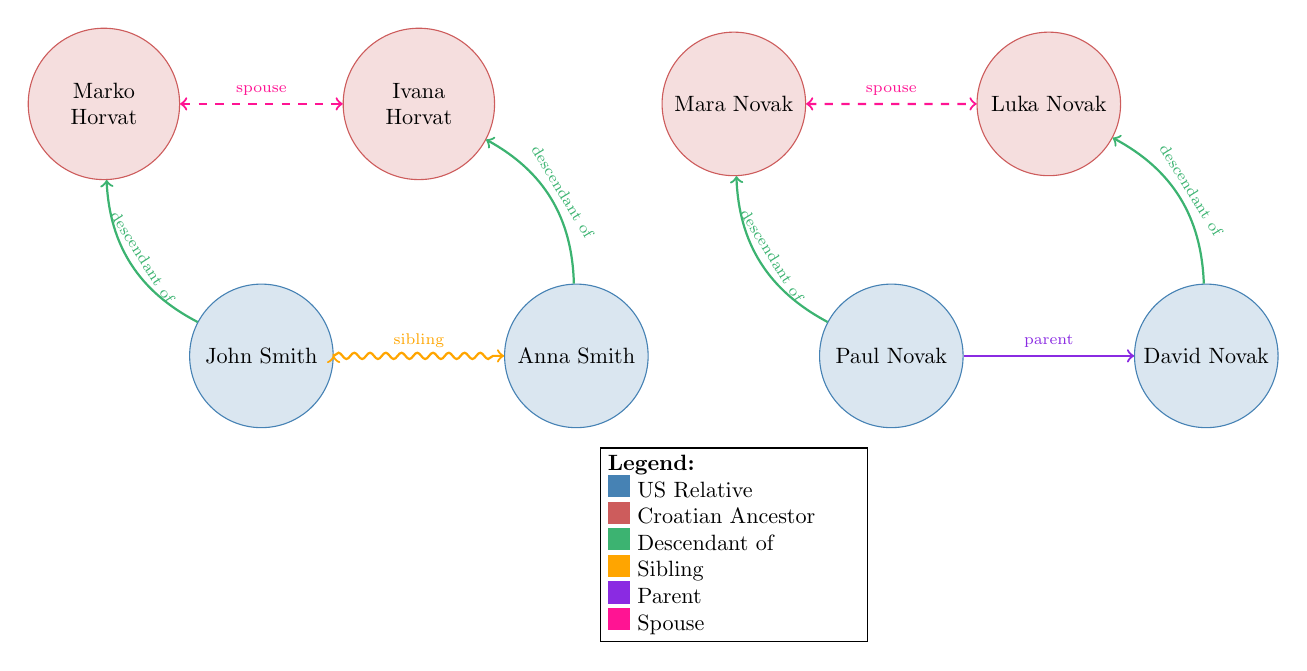What is the total number of nodes in the diagram? The diagram contains 8 distinct nodes, which represent both U.S. relatives and Croatian ancestors.
Answer: 8 Who is the spouse of Marko Horvat? The diagram indicates that Marko Horvat is married to Ivana Horvat, as shown by the dashed line labeled "spouse."
Answer: Ivana Horvat What is the relationship between John Smith and Anna Smith? John Smith and Anna Smith are connected by a snake-like line labeled "sibling," indicating they are siblings.
Answer: sibling How many Croatian ancestors are in the diagram? There are 4 nodes labeled as Croatian Ancestors: Marko Horvat, Ivana Horvat, Mara Novak, and Luka Novak.
Answer: 4 Who is the parent of David Novak? The diagram shows that Paul Novak is the parent of David Novak, as indicated by the solid line labeled "parent."
Answer: Paul Novak Which U.S. relative has two Croatian ancestors? John Smith has one Croatian ancestor, Marko Horvat, while Anna Smith has Ivana Horvat as her Croatian ancestor. Therefore, it can be concluded that neither John nor Anna has two Croatian ancestors.
Answer: None What type of relationship exists between Paul Novak and David Novak? The diagram clearly shows a solid line pointing from Paul Novak to David Novak with the label "parent," indicating that Paul is David's parent.
Answer: parent What color represents Croatian ancestors in the diagram? The Croatian ancestors are represented in red shades as defined by the RGB color (205,92,92) in the diagram's color legend.
Answer: red 